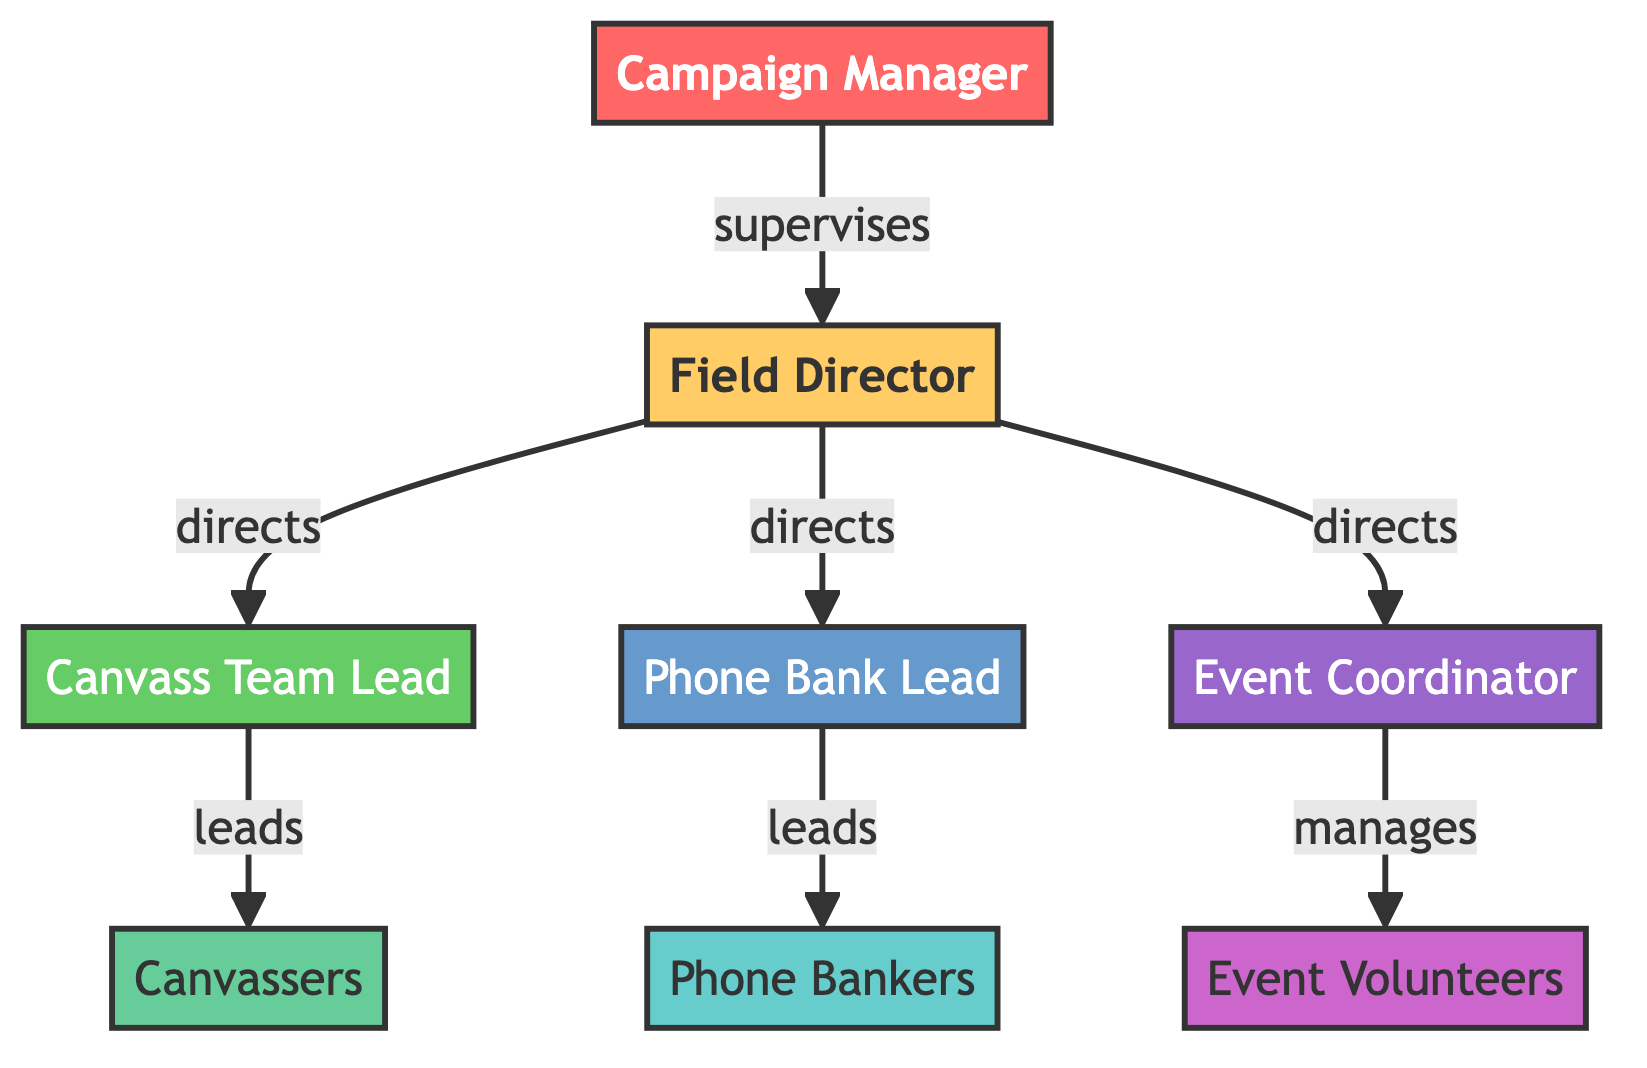What is the top position in the hierarchy? The top position in the hierarchy is the Campaign Manager, which is clearly represented at the top of the diagram.
Answer: Campaign Manager How many volunteers are directly supervised by the Field Director? The Field Director supervises three volunteers: the Canvass Team Lead, the Phone Bank Lead, and the Event Coordinator, as indicated by the edges connecting the nodes.
Answer: 3 Which role is responsible for leading the Canvassers? The role responsible for leading the Canvassers is the Canvass Team Lead, as shown by the direct line connecting these two positions in the diagram.
Answer: Canvass Team Lead What segment color represents the Event Coordinator? The Event Coordinator is represented by a segment with the color purple, which corresponds to the visual coding used in the diagram.
Answer: Purple How many nodes represent volunteer roles in total? The total number of nodes representing volunteer roles includes Canvassers, Phone Bankers, and Event Volunteers, summing up to six nodes in total.
Answer: 6 Who directs the Phone Bankers? The Phone Bank Lead directs the Phone Bankers, as indicated by the direct connection from the Phone Bank Lead to Phone Bankers in the diagram.
Answer: Phone Bank Lead What color represents the Phone Bank Lead? The Phone Bank Lead is represented by a segment colored blue in the diagram, reflecting the designated color coding for different roles.
Answer: Blue Which role manages the Event Volunteers? The Event Coordinator is the role that manages the Event Volunteers, indicated by the line connecting them in the flowchart.
Answer: Event Coordinator What is the role just below the Field Director? The roles just below the Field Director are the Canvass Team Lead, Phone Bank Lead, and Event Coordinator, showcasing the direct reporting structure in the diagram.
Answer: Canvass Team Lead, Phone Bank Lead, Event Coordinator 